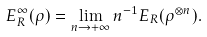<formula> <loc_0><loc_0><loc_500><loc_500>E ^ { \infty } _ { R } ( \rho ) = \lim _ { n \rightarrow + \infty } n ^ { - 1 } E _ { R } ( \rho ^ { \otimes n } ) .</formula> 